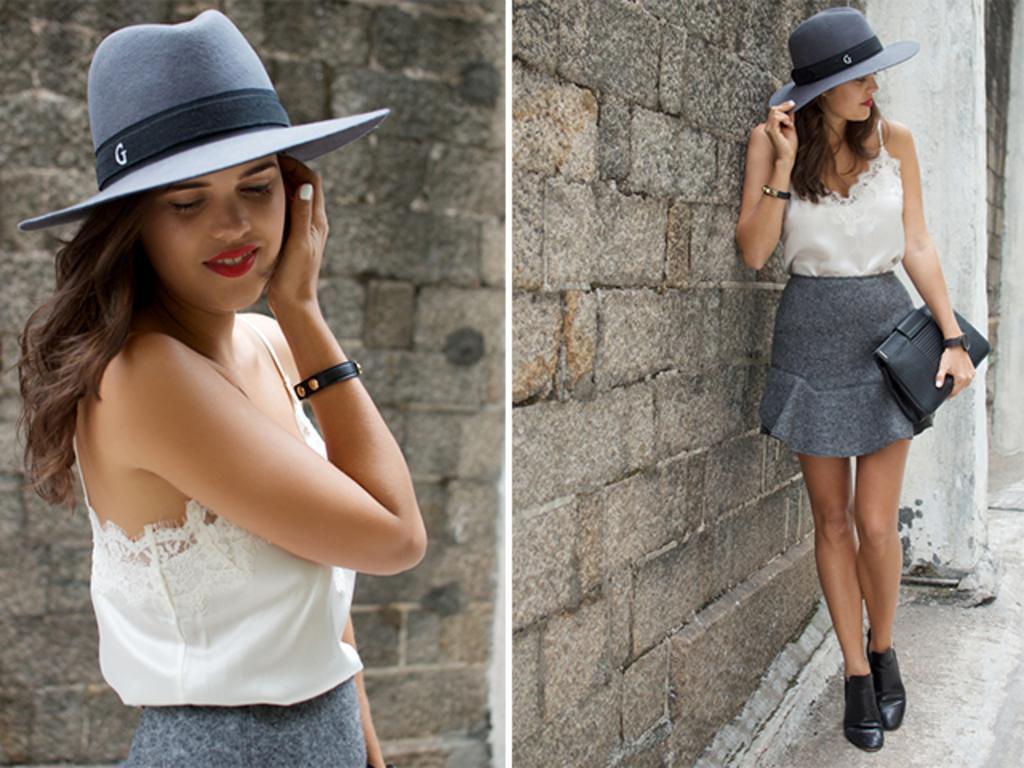Could you give a brief overview of what you see in this image? It is the collage of two images where we can see there is a girl in the middle. Behind her there is a wall. On the right side there is another girl who is standing by lying on the wall and holding the bag. 